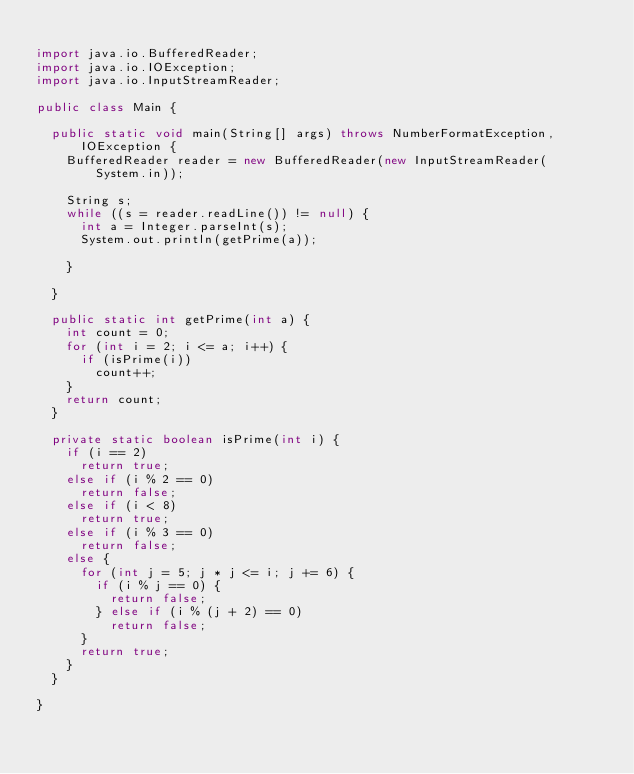<code> <loc_0><loc_0><loc_500><loc_500><_Java_>
import java.io.BufferedReader;
import java.io.IOException;
import java.io.InputStreamReader;

public class Main {

	public static void main(String[] args) throws NumberFormatException,
			IOException {
		BufferedReader reader = new BufferedReader(new InputStreamReader(
				System.in));

		String s;
		while ((s = reader.readLine()) != null) {
			int a = Integer.parseInt(s);
			System.out.println(getPrime(a));

		}

	}

	public static int getPrime(int a) {
		int count = 0;
		for (int i = 2; i <= a; i++) {
			if (isPrime(i))
				count++;
		}
		return count;
	}

	private static boolean isPrime(int i) {
		if (i == 2)
			return true;
		else if (i % 2 == 0)
			return false;
		else if (i < 8)
			return true;
		else if (i % 3 == 0)
			return false;
		else {
			for (int j = 5; j * j <= i; j += 6) {
				if (i % j == 0) {
					return false;
				} else if (i % (j + 2) == 0)
					return false;
			}
			return true;
		}
	}

}</code> 